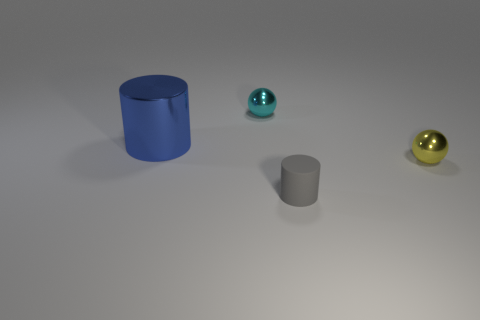What number of gray things are either big objects or tiny shiny things?
Ensure brevity in your answer.  0. Are there fewer large things right of the tiny cyan metal sphere than small cyan objects?
Offer a terse response. Yes. What number of tiny yellow spheres are left of the metal thing that is right of the tiny rubber object?
Keep it short and to the point. 0. How many other things are the same size as the gray thing?
Your answer should be compact. 2. What number of objects are either blue metallic objects or spheres in front of the big cylinder?
Give a very brief answer. 2. Are there fewer large gray things than objects?
Give a very brief answer. Yes. The metallic ball on the right side of the small shiny object left of the rubber cylinder is what color?
Ensure brevity in your answer.  Yellow. There is another big thing that is the same shape as the gray thing; what is it made of?
Make the answer very short. Metal. What number of metallic things are either big cylinders or small red cubes?
Offer a terse response. 1. Does the cylinder that is in front of the big blue cylinder have the same material as the small ball right of the cyan shiny sphere?
Your answer should be compact. No. 